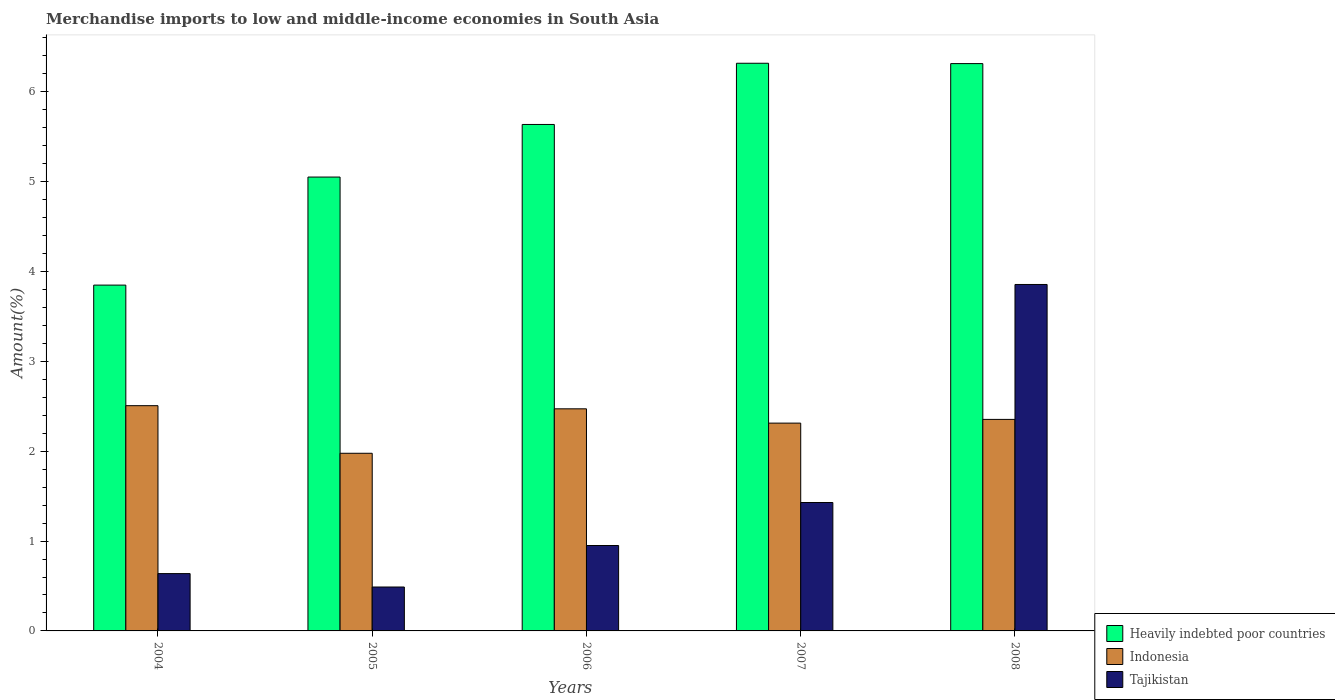How many different coloured bars are there?
Make the answer very short. 3. How many groups of bars are there?
Provide a short and direct response. 5. Are the number of bars per tick equal to the number of legend labels?
Make the answer very short. Yes. Are the number of bars on each tick of the X-axis equal?
Ensure brevity in your answer.  Yes. What is the label of the 3rd group of bars from the left?
Provide a short and direct response. 2006. What is the percentage of amount earned from merchandise imports in Indonesia in 2008?
Your answer should be compact. 2.35. Across all years, what is the maximum percentage of amount earned from merchandise imports in Heavily indebted poor countries?
Your answer should be compact. 6.32. Across all years, what is the minimum percentage of amount earned from merchandise imports in Tajikistan?
Your response must be concise. 0.49. In which year was the percentage of amount earned from merchandise imports in Heavily indebted poor countries maximum?
Provide a succinct answer. 2007. What is the total percentage of amount earned from merchandise imports in Tajikistan in the graph?
Ensure brevity in your answer.  7.36. What is the difference between the percentage of amount earned from merchandise imports in Indonesia in 2004 and that in 2007?
Ensure brevity in your answer.  0.19. What is the difference between the percentage of amount earned from merchandise imports in Indonesia in 2008 and the percentage of amount earned from merchandise imports in Tajikistan in 2005?
Ensure brevity in your answer.  1.87. What is the average percentage of amount earned from merchandise imports in Heavily indebted poor countries per year?
Your answer should be compact. 5.43. In the year 2006, what is the difference between the percentage of amount earned from merchandise imports in Tajikistan and percentage of amount earned from merchandise imports in Indonesia?
Your answer should be very brief. -1.52. In how many years, is the percentage of amount earned from merchandise imports in Indonesia greater than 6 %?
Your answer should be very brief. 0. What is the ratio of the percentage of amount earned from merchandise imports in Tajikistan in 2005 to that in 2007?
Your answer should be compact. 0.34. What is the difference between the highest and the second highest percentage of amount earned from merchandise imports in Heavily indebted poor countries?
Give a very brief answer. 0. What is the difference between the highest and the lowest percentage of amount earned from merchandise imports in Tajikistan?
Provide a succinct answer. 3.37. In how many years, is the percentage of amount earned from merchandise imports in Tajikistan greater than the average percentage of amount earned from merchandise imports in Tajikistan taken over all years?
Keep it short and to the point. 1. Is the sum of the percentage of amount earned from merchandise imports in Indonesia in 2006 and 2007 greater than the maximum percentage of amount earned from merchandise imports in Tajikistan across all years?
Offer a very short reply. Yes. What does the 1st bar from the left in 2008 represents?
Provide a succinct answer. Heavily indebted poor countries. What does the 3rd bar from the right in 2008 represents?
Keep it short and to the point. Heavily indebted poor countries. How many bars are there?
Make the answer very short. 15. How many years are there in the graph?
Provide a short and direct response. 5. Are the values on the major ticks of Y-axis written in scientific E-notation?
Ensure brevity in your answer.  No. Does the graph contain grids?
Make the answer very short. No. How are the legend labels stacked?
Keep it short and to the point. Vertical. What is the title of the graph?
Make the answer very short. Merchandise imports to low and middle-income economies in South Asia. Does "United Arab Emirates" appear as one of the legend labels in the graph?
Make the answer very short. No. What is the label or title of the Y-axis?
Provide a succinct answer. Amount(%). What is the Amount(%) in Heavily indebted poor countries in 2004?
Provide a short and direct response. 3.85. What is the Amount(%) of Indonesia in 2004?
Provide a short and direct response. 2.51. What is the Amount(%) in Tajikistan in 2004?
Your answer should be compact. 0.64. What is the Amount(%) in Heavily indebted poor countries in 2005?
Keep it short and to the point. 5.05. What is the Amount(%) in Indonesia in 2005?
Offer a very short reply. 1.98. What is the Amount(%) in Tajikistan in 2005?
Provide a succinct answer. 0.49. What is the Amount(%) in Heavily indebted poor countries in 2006?
Ensure brevity in your answer.  5.64. What is the Amount(%) in Indonesia in 2006?
Make the answer very short. 2.47. What is the Amount(%) in Tajikistan in 2006?
Ensure brevity in your answer.  0.95. What is the Amount(%) of Heavily indebted poor countries in 2007?
Give a very brief answer. 6.32. What is the Amount(%) of Indonesia in 2007?
Your response must be concise. 2.31. What is the Amount(%) of Tajikistan in 2007?
Ensure brevity in your answer.  1.43. What is the Amount(%) of Heavily indebted poor countries in 2008?
Your answer should be compact. 6.31. What is the Amount(%) of Indonesia in 2008?
Offer a very short reply. 2.35. What is the Amount(%) in Tajikistan in 2008?
Make the answer very short. 3.86. Across all years, what is the maximum Amount(%) of Heavily indebted poor countries?
Make the answer very short. 6.32. Across all years, what is the maximum Amount(%) in Indonesia?
Offer a terse response. 2.51. Across all years, what is the maximum Amount(%) of Tajikistan?
Make the answer very short. 3.86. Across all years, what is the minimum Amount(%) of Heavily indebted poor countries?
Provide a short and direct response. 3.85. Across all years, what is the minimum Amount(%) in Indonesia?
Offer a terse response. 1.98. Across all years, what is the minimum Amount(%) in Tajikistan?
Your answer should be very brief. 0.49. What is the total Amount(%) in Heavily indebted poor countries in the graph?
Offer a terse response. 27.16. What is the total Amount(%) of Indonesia in the graph?
Your answer should be very brief. 11.62. What is the total Amount(%) in Tajikistan in the graph?
Make the answer very short. 7.36. What is the difference between the Amount(%) in Heavily indebted poor countries in 2004 and that in 2005?
Your response must be concise. -1.2. What is the difference between the Amount(%) in Indonesia in 2004 and that in 2005?
Offer a terse response. 0.53. What is the difference between the Amount(%) in Tajikistan in 2004 and that in 2005?
Keep it short and to the point. 0.15. What is the difference between the Amount(%) in Heavily indebted poor countries in 2004 and that in 2006?
Your response must be concise. -1.79. What is the difference between the Amount(%) of Indonesia in 2004 and that in 2006?
Provide a short and direct response. 0.04. What is the difference between the Amount(%) of Tajikistan in 2004 and that in 2006?
Make the answer very short. -0.31. What is the difference between the Amount(%) of Heavily indebted poor countries in 2004 and that in 2007?
Your answer should be compact. -2.47. What is the difference between the Amount(%) of Indonesia in 2004 and that in 2007?
Offer a terse response. 0.19. What is the difference between the Amount(%) in Tajikistan in 2004 and that in 2007?
Offer a terse response. -0.79. What is the difference between the Amount(%) in Heavily indebted poor countries in 2004 and that in 2008?
Make the answer very short. -2.46. What is the difference between the Amount(%) of Indonesia in 2004 and that in 2008?
Offer a terse response. 0.15. What is the difference between the Amount(%) of Tajikistan in 2004 and that in 2008?
Ensure brevity in your answer.  -3.22. What is the difference between the Amount(%) of Heavily indebted poor countries in 2005 and that in 2006?
Offer a terse response. -0.59. What is the difference between the Amount(%) of Indonesia in 2005 and that in 2006?
Offer a terse response. -0.49. What is the difference between the Amount(%) in Tajikistan in 2005 and that in 2006?
Ensure brevity in your answer.  -0.46. What is the difference between the Amount(%) in Heavily indebted poor countries in 2005 and that in 2007?
Provide a short and direct response. -1.27. What is the difference between the Amount(%) of Indonesia in 2005 and that in 2007?
Offer a very short reply. -0.34. What is the difference between the Amount(%) in Tajikistan in 2005 and that in 2007?
Offer a terse response. -0.94. What is the difference between the Amount(%) in Heavily indebted poor countries in 2005 and that in 2008?
Ensure brevity in your answer.  -1.26. What is the difference between the Amount(%) in Indonesia in 2005 and that in 2008?
Make the answer very short. -0.38. What is the difference between the Amount(%) in Tajikistan in 2005 and that in 2008?
Give a very brief answer. -3.37. What is the difference between the Amount(%) of Heavily indebted poor countries in 2006 and that in 2007?
Your answer should be compact. -0.68. What is the difference between the Amount(%) of Indonesia in 2006 and that in 2007?
Provide a short and direct response. 0.16. What is the difference between the Amount(%) in Tajikistan in 2006 and that in 2007?
Provide a short and direct response. -0.48. What is the difference between the Amount(%) of Heavily indebted poor countries in 2006 and that in 2008?
Make the answer very short. -0.68. What is the difference between the Amount(%) in Indonesia in 2006 and that in 2008?
Provide a succinct answer. 0.12. What is the difference between the Amount(%) in Tajikistan in 2006 and that in 2008?
Your answer should be compact. -2.9. What is the difference between the Amount(%) of Heavily indebted poor countries in 2007 and that in 2008?
Keep it short and to the point. 0. What is the difference between the Amount(%) in Indonesia in 2007 and that in 2008?
Your response must be concise. -0.04. What is the difference between the Amount(%) of Tajikistan in 2007 and that in 2008?
Keep it short and to the point. -2.43. What is the difference between the Amount(%) of Heavily indebted poor countries in 2004 and the Amount(%) of Indonesia in 2005?
Your answer should be compact. 1.87. What is the difference between the Amount(%) of Heavily indebted poor countries in 2004 and the Amount(%) of Tajikistan in 2005?
Your answer should be compact. 3.36. What is the difference between the Amount(%) of Indonesia in 2004 and the Amount(%) of Tajikistan in 2005?
Ensure brevity in your answer.  2.02. What is the difference between the Amount(%) in Heavily indebted poor countries in 2004 and the Amount(%) in Indonesia in 2006?
Your answer should be compact. 1.38. What is the difference between the Amount(%) of Heavily indebted poor countries in 2004 and the Amount(%) of Tajikistan in 2006?
Your answer should be compact. 2.9. What is the difference between the Amount(%) of Indonesia in 2004 and the Amount(%) of Tajikistan in 2006?
Ensure brevity in your answer.  1.56. What is the difference between the Amount(%) in Heavily indebted poor countries in 2004 and the Amount(%) in Indonesia in 2007?
Your response must be concise. 1.54. What is the difference between the Amount(%) in Heavily indebted poor countries in 2004 and the Amount(%) in Tajikistan in 2007?
Your response must be concise. 2.42. What is the difference between the Amount(%) in Indonesia in 2004 and the Amount(%) in Tajikistan in 2007?
Your response must be concise. 1.08. What is the difference between the Amount(%) in Heavily indebted poor countries in 2004 and the Amount(%) in Indonesia in 2008?
Make the answer very short. 1.49. What is the difference between the Amount(%) of Heavily indebted poor countries in 2004 and the Amount(%) of Tajikistan in 2008?
Offer a very short reply. -0.01. What is the difference between the Amount(%) in Indonesia in 2004 and the Amount(%) in Tajikistan in 2008?
Provide a short and direct response. -1.35. What is the difference between the Amount(%) of Heavily indebted poor countries in 2005 and the Amount(%) of Indonesia in 2006?
Provide a short and direct response. 2.58. What is the difference between the Amount(%) in Heavily indebted poor countries in 2005 and the Amount(%) in Tajikistan in 2006?
Offer a very short reply. 4.1. What is the difference between the Amount(%) in Indonesia in 2005 and the Amount(%) in Tajikistan in 2006?
Give a very brief answer. 1.03. What is the difference between the Amount(%) of Heavily indebted poor countries in 2005 and the Amount(%) of Indonesia in 2007?
Make the answer very short. 2.74. What is the difference between the Amount(%) of Heavily indebted poor countries in 2005 and the Amount(%) of Tajikistan in 2007?
Give a very brief answer. 3.62. What is the difference between the Amount(%) in Indonesia in 2005 and the Amount(%) in Tajikistan in 2007?
Make the answer very short. 0.55. What is the difference between the Amount(%) in Heavily indebted poor countries in 2005 and the Amount(%) in Indonesia in 2008?
Ensure brevity in your answer.  2.7. What is the difference between the Amount(%) of Heavily indebted poor countries in 2005 and the Amount(%) of Tajikistan in 2008?
Your answer should be compact. 1.2. What is the difference between the Amount(%) of Indonesia in 2005 and the Amount(%) of Tajikistan in 2008?
Your response must be concise. -1.88. What is the difference between the Amount(%) in Heavily indebted poor countries in 2006 and the Amount(%) in Indonesia in 2007?
Your response must be concise. 3.32. What is the difference between the Amount(%) in Heavily indebted poor countries in 2006 and the Amount(%) in Tajikistan in 2007?
Offer a very short reply. 4.21. What is the difference between the Amount(%) in Indonesia in 2006 and the Amount(%) in Tajikistan in 2007?
Your answer should be compact. 1.04. What is the difference between the Amount(%) of Heavily indebted poor countries in 2006 and the Amount(%) of Indonesia in 2008?
Provide a succinct answer. 3.28. What is the difference between the Amount(%) in Heavily indebted poor countries in 2006 and the Amount(%) in Tajikistan in 2008?
Provide a short and direct response. 1.78. What is the difference between the Amount(%) of Indonesia in 2006 and the Amount(%) of Tajikistan in 2008?
Make the answer very short. -1.38. What is the difference between the Amount(%) in Heavily indebted poor countries in 2007 and the Amount(%) in Indonesia in 2008?
Keep it short and to the point. 3.96. What is the difference between the Amount(%) of Heavily indebted poor countries in 2007 and the Amount(%) of Tajikistan in 2008?
Your answer should be compact. 2.46. What is the difference between the Amount(%) of Indonesia in 2007 and the Amount(%) of Tajikistan in 2008?
Your answer should be very brief. -1.54. What is the average Amount(%) in Heavily indebted poor countries per year?
Keep it short and to the point. 5.43. What is the average Amount(%) in Indonesia per year?
Provide a succinct answer. 2.32. What is the average Amount(%) in Tajikistan per year?
Make the answer very short. 1.47. In the year 2004, what is the difference between the Amount(%) in Heavily indebted poor countries and Amount(%) in Indonesia?
Provide a short and direct response. 1.34. In the year 2004, what is the difference between the Amount(%) of Heavily indebted poor countries and Amount(%) of Tajikistan?
Your answer should be very brief. 3.21. In the year 2004, what is the difference between the Amount(%) in Indonesia and Amount(%) in Tajikistan?
Provide a short and direct response. 1.87. In the year 2005, what is the difference between the Amount(%) of Heavily indebted poor countries and Amount(%) of Indonesia?
Ensure brevity in your answer.  3.07. In the year 2005, what is the difference between the Amount(%) of Heavily indebted poor countries and Amount(%) of Tajikistan?
Give a very brief answer. 4.56. In the year 2005, what is the difference between the Amount(%) of Indonesia and Amount(%) of Tajikistan?
Offer a terse response. 1.49. In the year 2006, what is the difference between the Amount(%) of Heavily indebted poor countries and Amount(%) of Indonesia?
Your answer should be compact. 3.16. In the year 2006, what is the difference between the Amount(%) in Heavily indebted poor countries and Amount(%) in Tajikistan?
Give a very brief answer. 4.69. In the year 2006, what is the difference between the Amount(%) of Indonesia and Amount(%) of Tajikistan?
Give a very brief answer. 1.52. In the year 2007, what is the difference between the Amount(%) of Heavily indebted poor countries and Amount(%) of Indonesia?
Offer a terse response. 4. In the year 2007, what is the difference between the Amount(%) in Heavily indebted poor countries and Amount(%) in Tajikistan?
Offer a very short reply. 4.89. In the year 2007, what is the difference between the Amount(%) in Indonesia and Amount(%) in Tajikistan?
Keep it short and to the point. 0.88. In the year 2008, what is the difference between the Amount(%) in Heavily indebted poor countries and Amount(%) in Indonesia?
Your answer should be compact. 3.96. In the year 2008, what is the difference between the Amount(%) in Heavily indebted poor countries and Amount(%) in Tajikistan?
Ensure brevity in your answer.  2.46. In the year 2008, what is the difference between the Amount(%) in Indonesia and Amount(%) in Tajikistan?
Ensure brevity in your answer.  -1.5. What is the ratio of the Amount(%) of Heavily indebted poor countries in 2004 to that in 2005?
Your answer should be compact. 0.76. What is the ratio of the Amount(%) of Indonesia in 2004 to that in 2005?
Provide a succinct answer. 1.27. What is the ratio of the Amount(%) in Tajikistan in 2004 to that in 2005?
Give a very brief answer. 1.31. What is the ratio of the Amount(%) in Heavily indebted poor countries in 2004 to that in 2006?
Provide a succinct answer. 0.68. What is the ratio of the Amount(%) of Indonesia in 2004 to that in 2006?
Keep it short and to the point. 1.01. What is the ratio of the Amount(%) in Tajikistan in 2004 to that in 2006?
Offer a terse response. 0.67. What is the ratio of the Amount(%) of Heavily indebted poor countries in 2004 to that in 2007?
Provide a short and direct response. 0.61. What is the ratio of the Amount(%) of Indonesia in 2004 to that in 2007?
Your response must be concise. 1.08. What is the ratio of the Amount(%) in Tajikistan in 2004 to that in 2007?
Offer a terse response. 0.45. What is the ratio of the Amount(%) in Heavily indebted poor countries in 2004 to that in 2008?
Give a very brief answer. 0.61. What is the ratio of the Amount(%) of Indonesia in 2004 to that in 2008?
Give a very brief answer. 1.06. What is the ratio of the Amount(%) in Tajikistan in 2004 to that in 2008?
Offer a terse response. 0.17. What is the ratio of the Amount(%) in Heavily indebted poor countries in 2005 to that in 2006?
Provide a short and direct response. 0.9. What is the ratio of the Amount(%) in Indonesia in 2005 to that in 2006?
Provide a succinct answer. 0.8. What is the ratio of the Amount(%) of Tajikistan in 2005 to that in 2006?
Keep it short and to the point. 0.51. What is the ratio of the Amount(%) in Heavily indebted poor countries in 2005 to that in 2007?
Give a very brief answer. 0.8. What is the ratio of the Amount(%) in Indonesia in 2005 to that in 2007?
Provide a succinct answer. 0.85. What is the ratio of the Amount(%) in Tajikistan in 2005 to that in 2007?
Your answer should be very brief. 0.34. What is the ratio of the Amount(%) of Heavily indebted poor countries in 2005 to that in 2008?
Ensure brevity in your answer.  0.8. What is the ratio of the Amount(%) of Indonesia in 2005 to that in 2008?
Offer a terse response. 0.84. What is the ratio of the Amount(%) in Tajikistan in 2005 to that in 2008?
Your answer should be very brief. 0.13. What is the ratio of the Amount(%) in Heavily indebted poor countries in 2006 to that in 2007?
Your answer should be compact. 0.89. What is the ratio of the Amount(%) in Indonesia in 2006 to that in 2007?
Offer a terse response. 1.07. What is the ratio of the Amount(%) of Tajikistan in 2006 to that in 2007?
Give a very brief answer. 0.67. What is the ratio of the Amount(%) in Heavily indebted poor countries in 2006 to that in 2008?
Offer a very short reply. 0.89. What is the ratio of the Amount(%) of Tajikistan in 2006 to that in 2008?
Your response must be concise. 0.25. What is the ratio of the Amount(%) of Indonesia in 2007 to that in 2008?
Keep it short and to the point. 0.98. What is the ratio of the Amount(%) of Tajikistan in 2007 to that in 2008?
Your answer should be compact. 0.37. What is the difference between the highest and the second highest Amount(%) of Heavily indebted poor countries?
Make the answer very short. 0. What is the difference between the highest and the second highest Amount(%) in Indonesia?
Provide a short and direct response. 0.04. What is the difference between the highest and the second highest Amount(%) of Tajikistan?
Give a very brief answer. 2.43. What is the difference between the highest and the lowest Amount(%) of Heavily indebted poor countries?
Your answer should be compact. 2.47. What is the difference between the highest and the lowest Amount(%) of Indonesia?
Provide a short and direct response. 0.53. What is the difference between the highest and the lowest Amount(%) of Tajikistan?
Give a very brief answer. 3.37. 